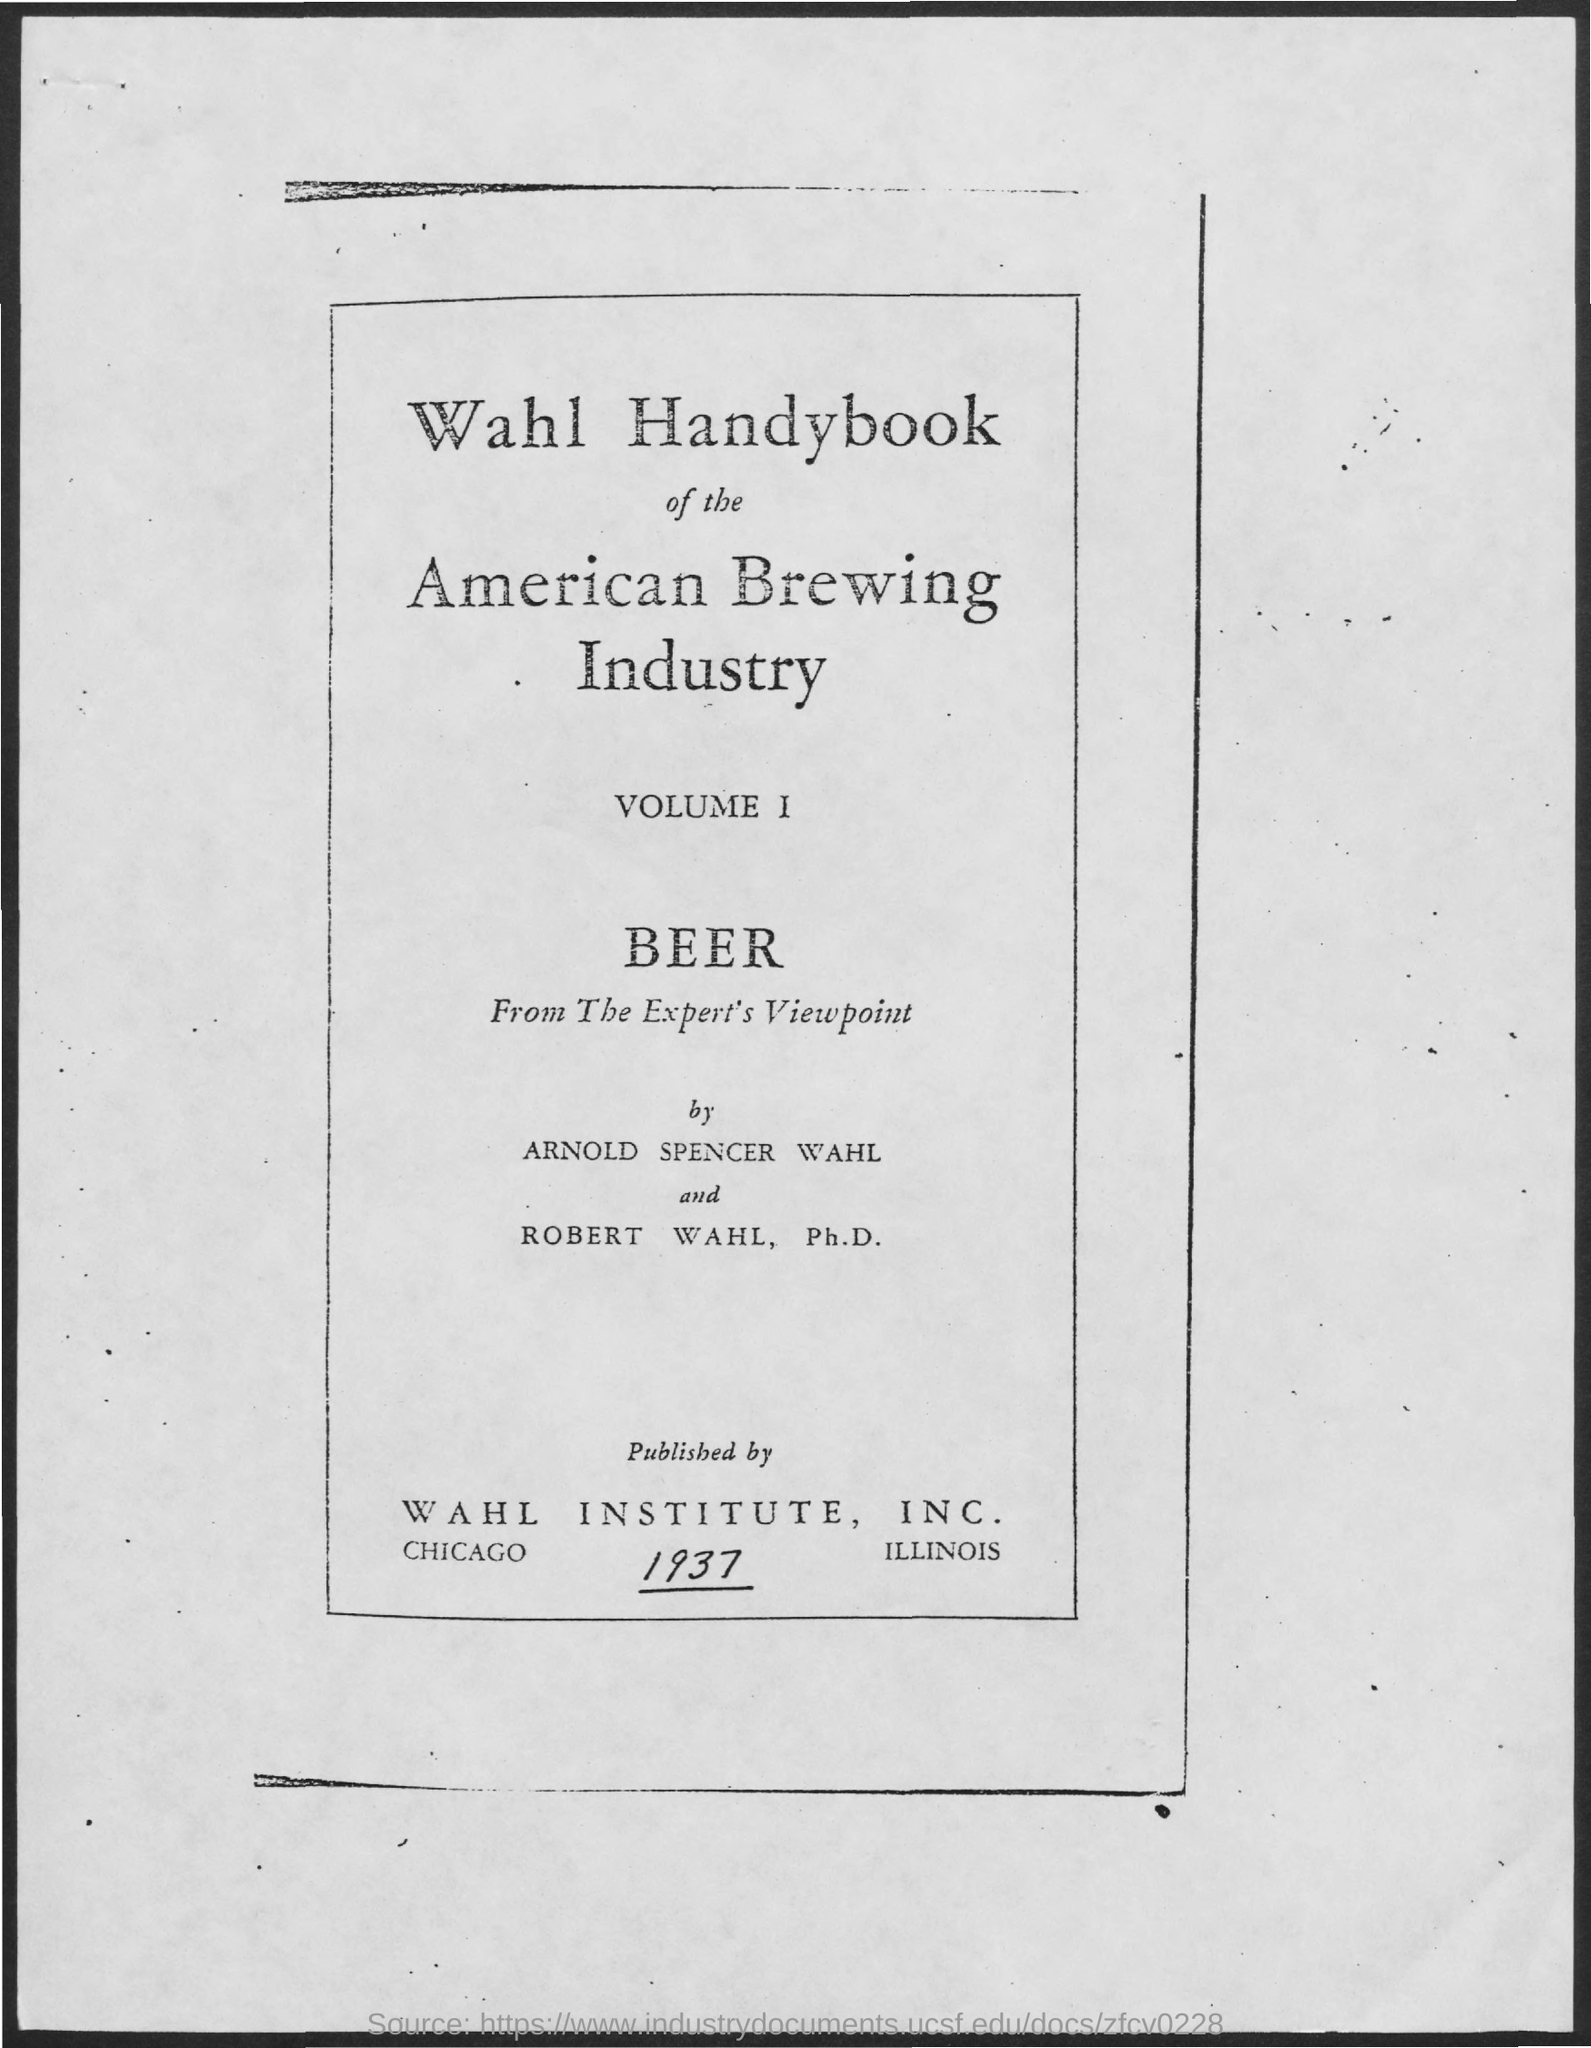Point out several critical features in this image. The authors of the Wahl Handybook of the American Brewing Industry are Arnold Spencer Wahl and Robert Wahl, Ph.D. The Wahl Handybook of the American Brewing Industry was published by the Wahl Institute, Inc. 